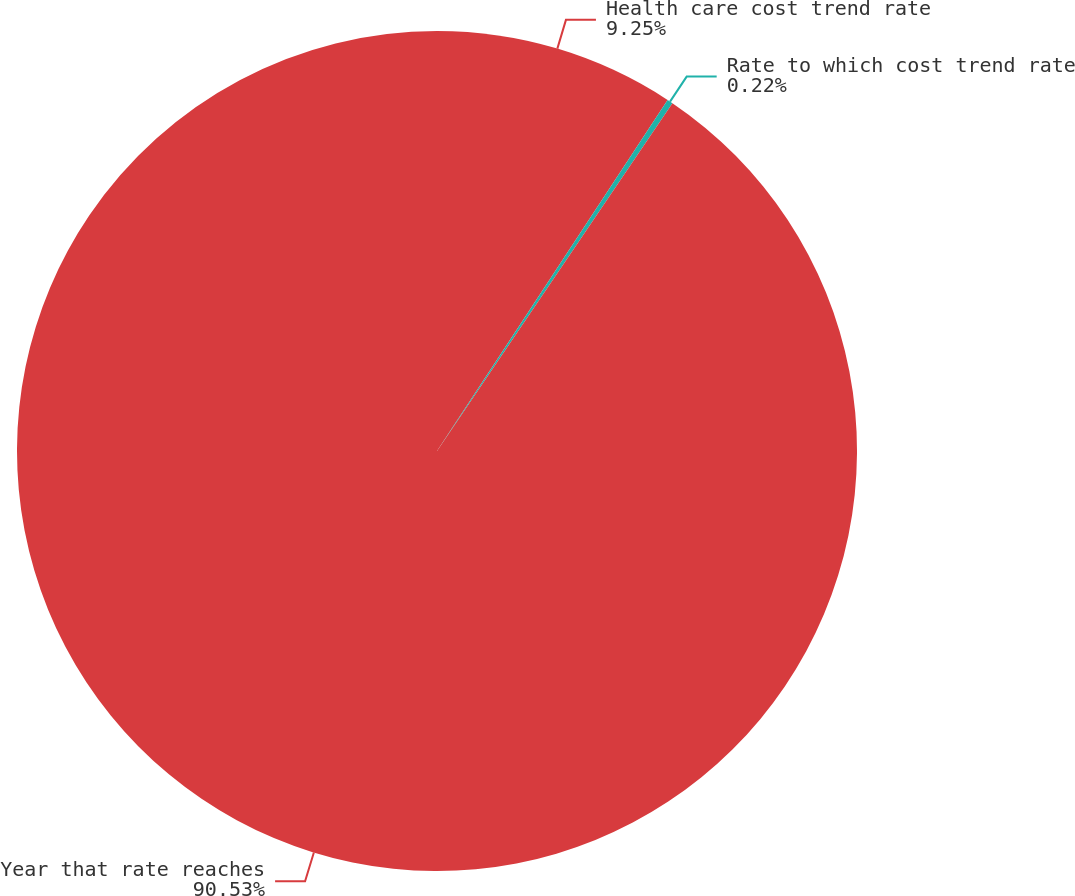Convert chart to OTSL. <chart><loc_0><loc_0><loc_500><loc_500><pie_chart><fcel>Health care cost trend rate<fcel>Rate to which cost trend rate<fcel>Year that rate reaches<nl><fcel>9.25%<fcel>0.22%<fcel>90.52%<nl></chart> 